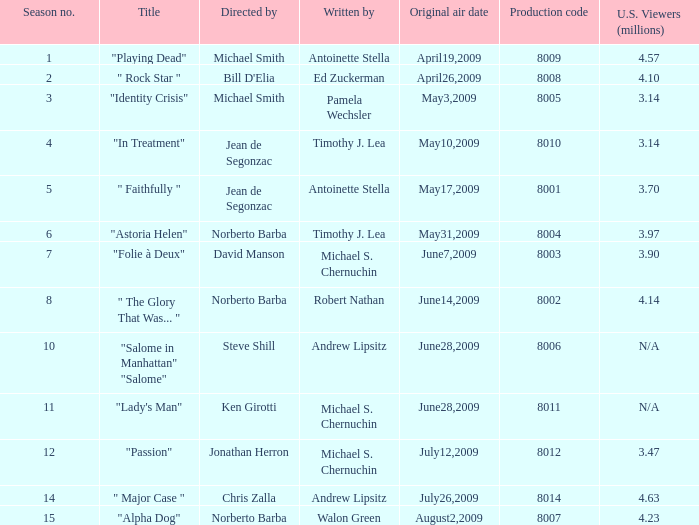How many authors compose the episode with jonathan herron as the director? 1.0. 